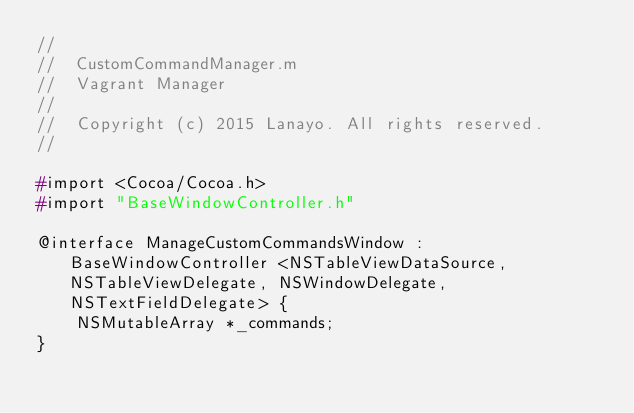Convert code to text. <code><loc_0><loc_0><loc_500><loc_500><_C_>//
//  CustomCommandManager.m
//  Vagrant Manager
//
//  Copyright (c) 2015 Lanayo. All rights reserved.
//

#import <Cocoa/Cocoa.h>
#import "BaseWindowController.h"

@interface ManageCustomCommandsWindow : BaseWindowController <NSTableViewDataSource, NSTableViewDelegate, NSWindowDelegate, NSTextFieldDelegate> {
    NSMutableArray *_commands;
}
</code> 